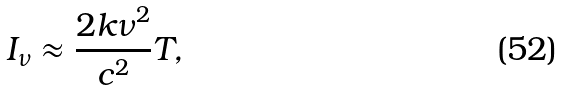Convert formula to latex. <formula><loc_0><loc_0><loc_500><loc_500>I _ { \nu } \approx \frac { 2 k \nu ^ { 2 } } { c ^ { 2 } } T ,</formula> 